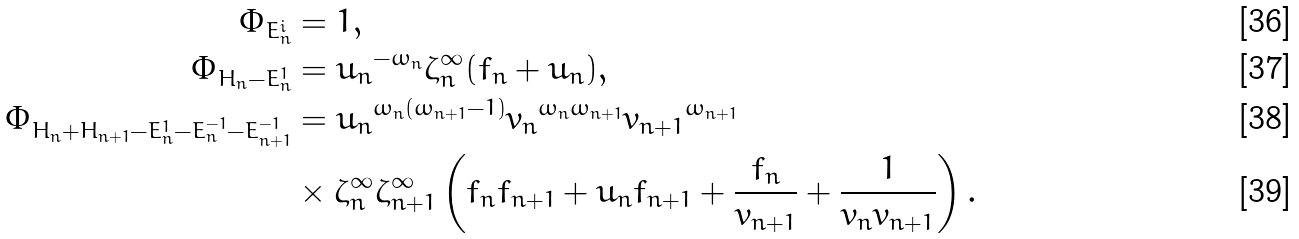Convert formula to latex. <formula><loc_0><loc_0><loc_500><loc_500>\Phi _ { E _ { n } ^ { i } } & = 1 , \\ \Phi _ { H _ { n } - E _ { n } ^ { 1 } } & = { u _ { n } } ^ { - \omega _ { n } } \zeta _ { n } ^ { \infty } ( f _ { n } + u _ { n } ) , \\ \Phi _ { H _ { n } + H _ { n + 1 } - E _ { n } ^ { 1 } - E _ { n } ^ { - 1 } - E _ { n + 1 } ^ { - 1 } } & = { u _ { n } } ^ { \omega _ { n } ( \omega _ { n + 1 } - 1 ) } { v _ { n } } ^ { \omega _ { n } \omega _ { n + 1 } } { v _ { n + 1 } } ^ { \omega _ { n + 1 } } \\ & \times \zeta _ { n } ^ { \infty } \zeta _ { n + 1 } ^ { \infty } \left ( f _ { n } f _ { n + 1 } + u _ { n } f _ { n + 1 } + \frac { f _ { n } } { v _ { n + 1 } } + \frac { 1 } { v _ { n } v _ { n + 1 } } \right ) .</formula> 